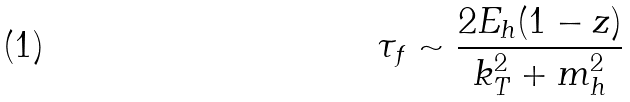Convert formula to latex. <formula><loc_0><loc_0><loc_500><loc_500>\tau _ { f } \sim \frac { 2 E _ { h } ( 1 - z ) } { k _ { T } ^ { 2 } + m _ { h } ^ { 2 } }</formula> 